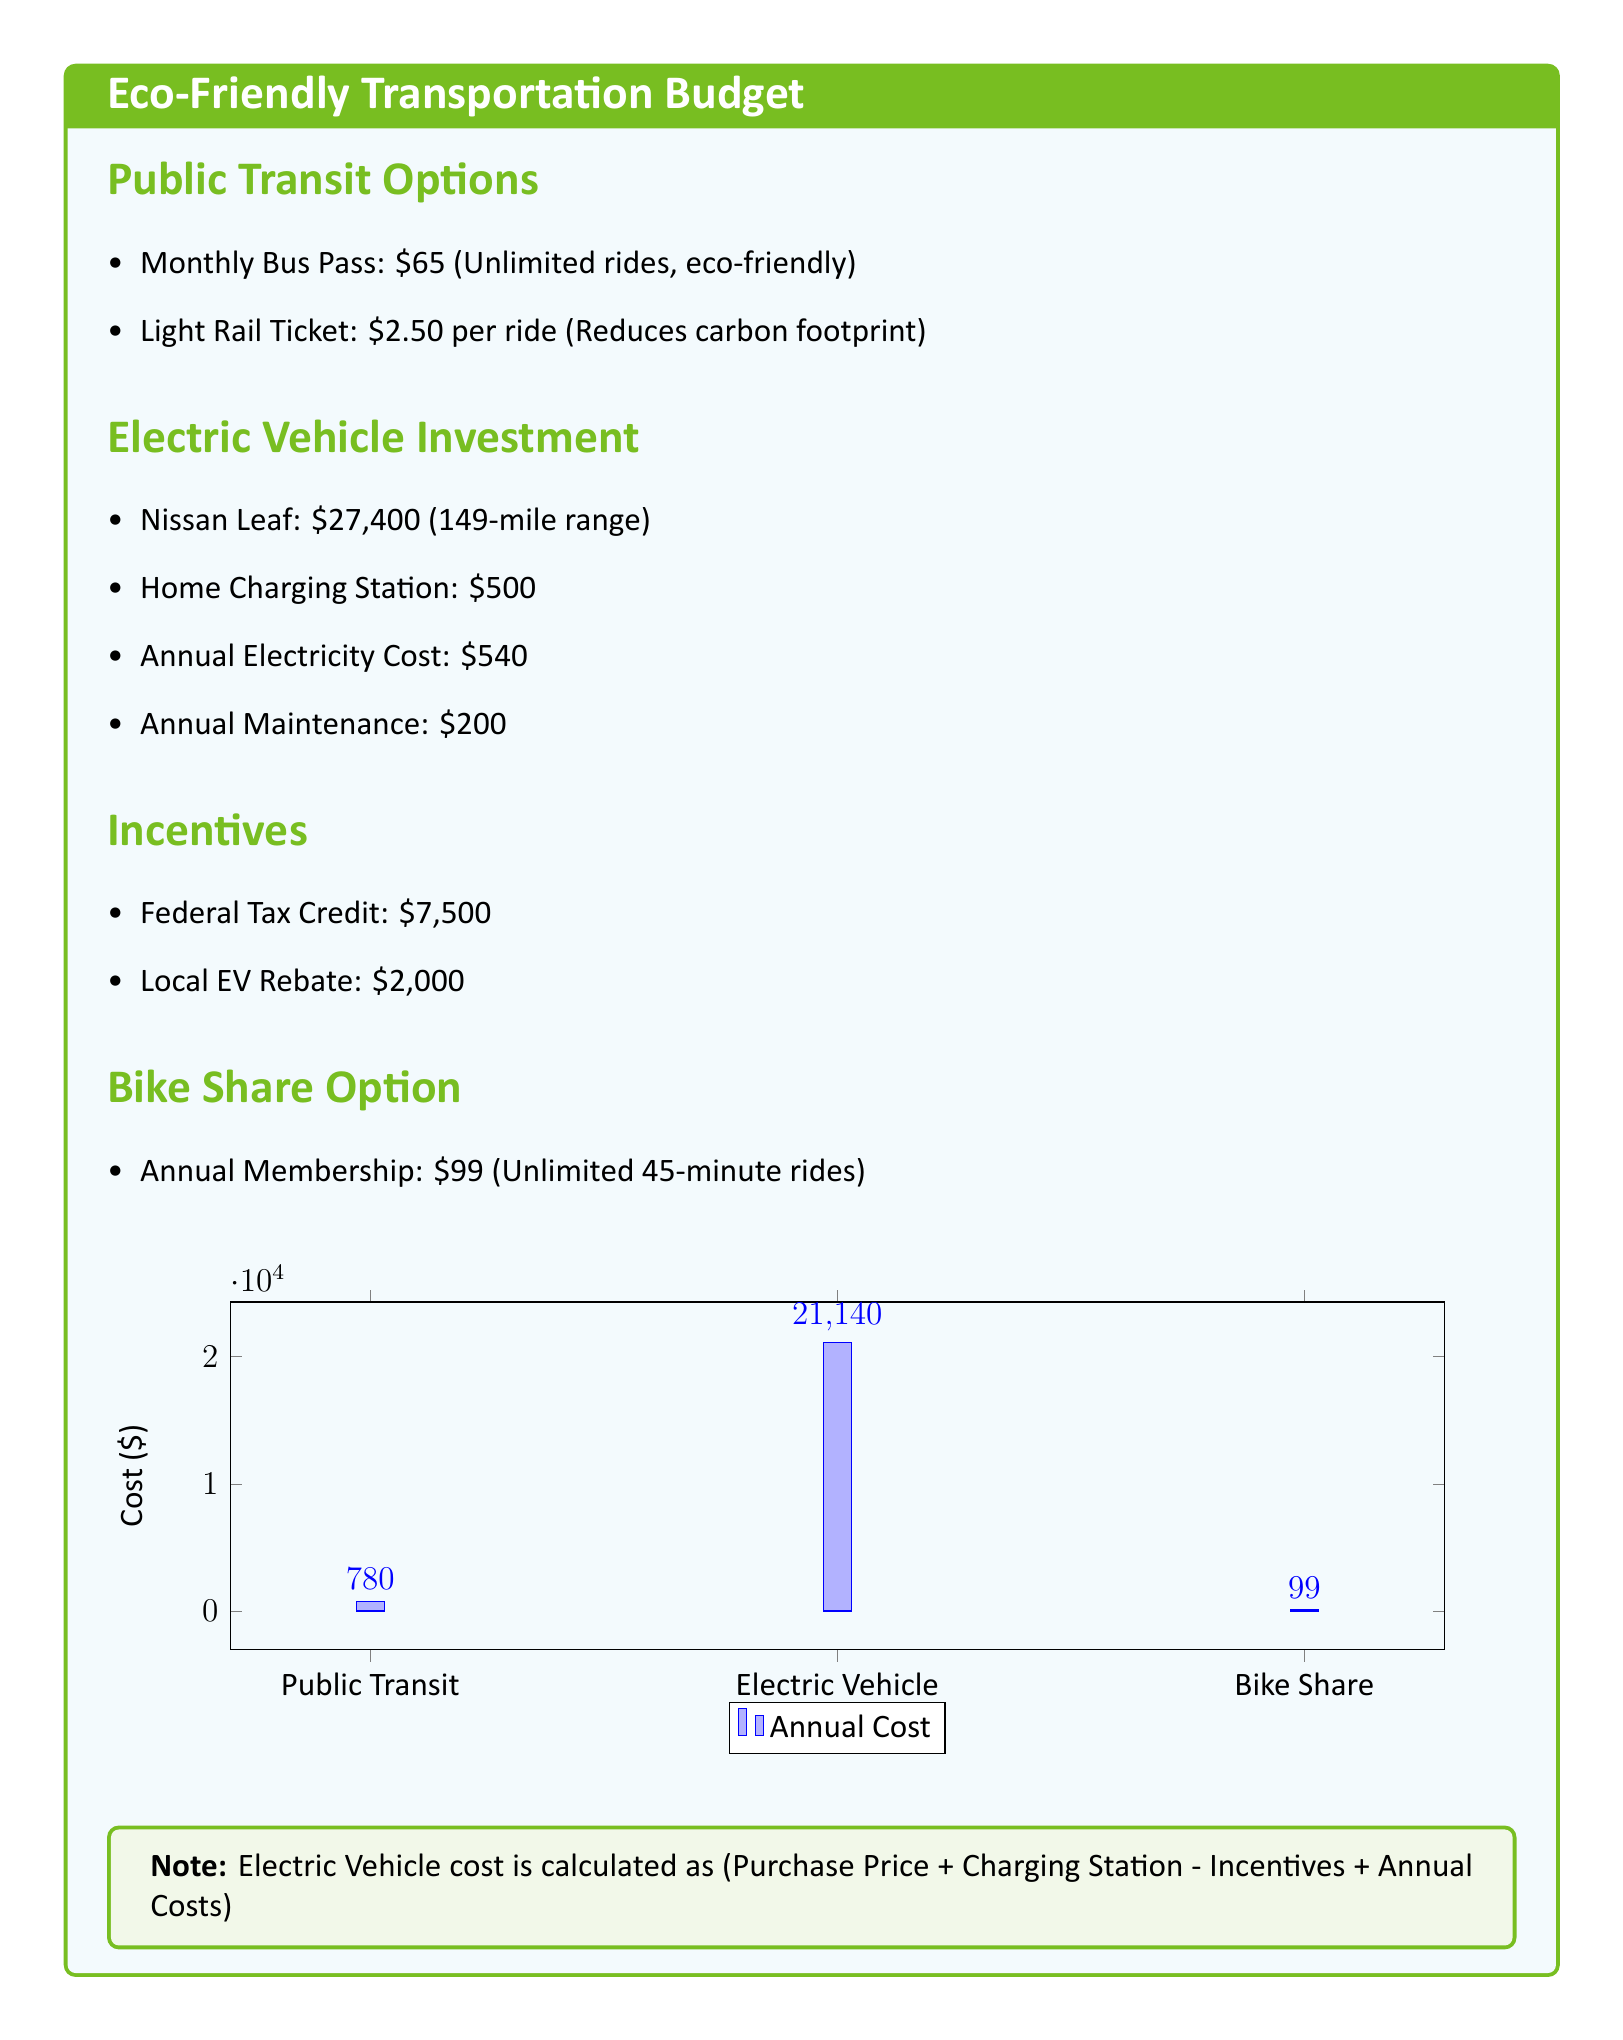What is the monthly cost of a bus pass? The document states the monthly bus pass costs $65.
Answer: $65 How much does a Light Rail ticket cost per ride? The document lists the cost of a Light Rail ticket as $2.50 per ride.
Answer: $2.50 What is the purchase price of the Nissan Leaf? The document specifies the purchase price of the Nissan Leaf as $27,400.
Answer: $27,400 What is the annual electricity cost for the electric vehicle? According to the document, the annual electricity cost is $540.
Answer: $540 What is the annual cost for bike share membership? The document mentions that the annual membership for bike share is $99.
Answer: $99 What are the total annual costs associated with the electric vehicle after incentives? The document provides the formula for calculating the electric vehicle cost, which after incentives is $21,140.
Answer: $21,140 What is the total amount of federal and local incentives combined? The document lists the federal tax credit as $7,500 and the local EV rebate as $2,000, totaling $9,500.
Answer: $9,500 What is the total projected annual transportation cost for Public Transit? The document quantifies the annual cost for Public Transit as $780.
Answer: $780 